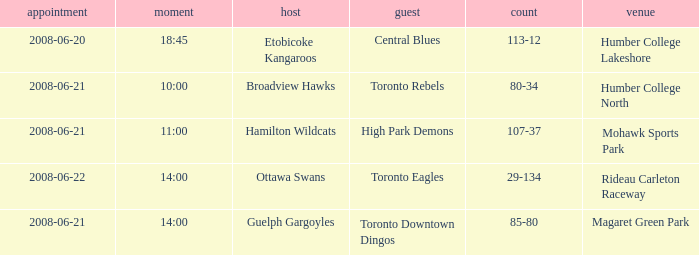What is the Time with a Score that is 80-34? 10:00. 